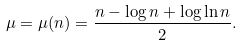Convert formula to latex. <formula><loc_0><loc_0><loc_500><loc_500>\mu = \mu ( n ) = \frac { n - \log n + \log \ln n } { 2 } .</formula> 